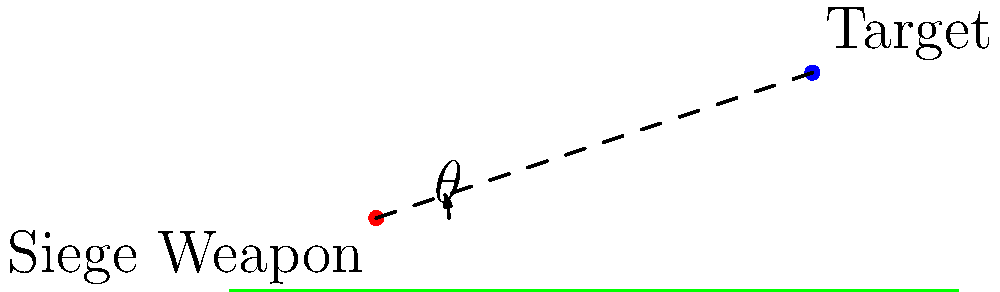In a Warhammer 40k battlefield scenario, a Basilisk artillery piece is positioned at coordinates (20m, 10m) and needs to target an enemy fortification at (80m, 30m). Assuming no air resistance and using a flat Earth model for simplicity, what is the optimal firing angle $\theta$ (in degrees) for the Basilisk to hit the target? To find the optimal firing angle, we'll use the principles of projectile motion:

1. Calculate the horizontal and vertical distances:
   Horizontal distance: $\Delta x = 80 - 20 = 60$ m
   Vertical distance: $\Delta y = 30 - 10 = 20$ m

2. Use the formula for the optimal angle in projectile motion:
   $\theta = \frac{1}{2} \arctan(\frac{2\Delta y}{\Delta x})$

3. Substitute the values:
   $\theta = \frac{1}{2} \arctan(\frac{2 \cdot 20}{60})$
   $\theta = \frac{1}{2} \arctan(\frac{40}{60})$

4. Simplify:
   $\theta = \frac{1}{2} \arctan(\frac{2}{3})$

5. Calculate the result:
   $\theta \approx 16.70°$

6. Round to the nearest degree:
   $\theta \approx 17°$

This angle will provide the optimal trajectory for the Basilisk to hit the target, assuming ideal conditions in the Warhammer 40k battlefield.
Answer: 17° 